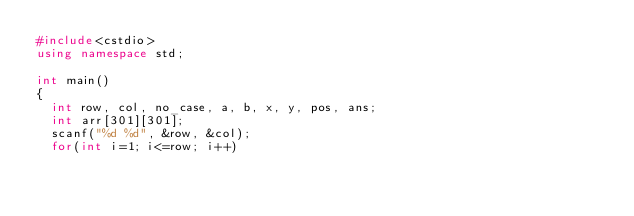<code> <loc_0><loc_0><loc_500><loc_500><_C++_>#include<cstdio>
using namespace std;

int main()
{
	int row, col, no_case, a, b, x, y, pos, ans;
	int arr[301][301];
	scanf("%d %d", &row, &col);
	for(int i=1; i<=row; i++)</code> 